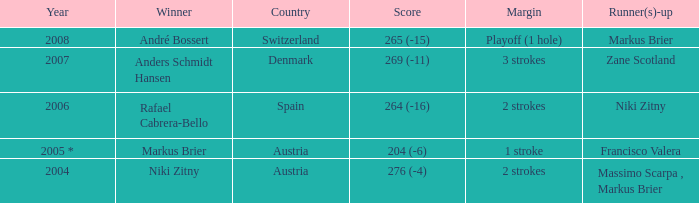In what year was the score 204 (-6)? 2005 *. Parse the table in full. {'header': ['Year', 'Winner', 'Country', 'Score', 'Margin', 'Runner(s)-up'], 'rows': [['2008', 'André Bossert', 'Switzerland', '265 (-15)', 'Playoff (1 hole)', 'Markus Brier'], ['2007', 'Anders Schmidt Hansen', 'Denmark', '269 (-11)', '3 strokes', 'Zane Scotland'], ['2006', 'Rafael Cabrera-Bello', 'Spain', '264 (-16)', '2 strokes', 'Niki Zitny'], ['2005 *', 'Markus Brier', 'Austria', '204 (-6)', '1 stroke', 'Francisco Valera'], ['2004', 'Niki Zitny', 'Austria', '276 (-4)', '2 strokes', 'Massimo Scarpa , Markus Brier']]} 